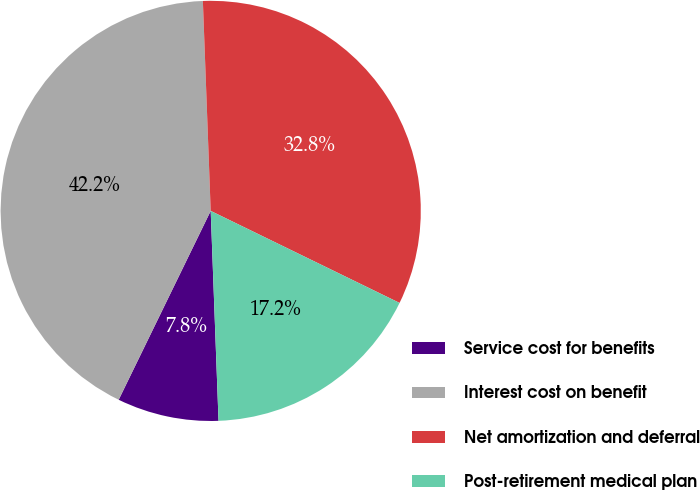Convert chart to OTSL. <chart><loc_0><loc_0><loc_500><loc_500><pie_chart><fcel>Service cost for benefits<fcel>Interest cost on benefit<fcel>Net amortization and deferral<fcel>Post-retirement medical plan<nl><fcel>7.81%<fcel>42.19%<fcel>32.81%<fcel>17.19%<nl></chart> 